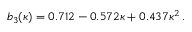<formula> <loc_0><loc_0><loc_500><loc_500>b _ { 3 } ( \kappa ) = 0 . 7 1 2 - 0 . 5 7 2 \kappa + 0 . 4 3 7 \kappa ^ { 2 } \, .</formula> 